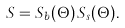Convert formula to latex. <formula><loc_0><loc_0><loc_500><loc_500>S = S _ { b } ( \Theta ) \, S _ { s } ( \Theta ) .</formula> 